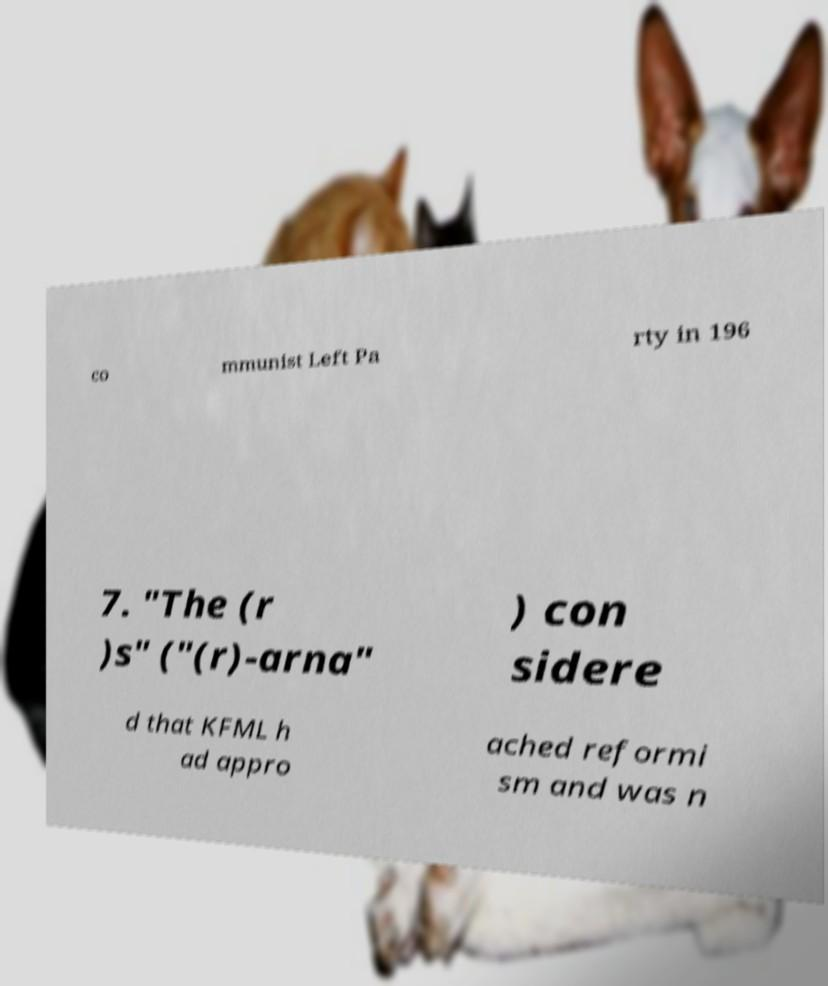Could you extract and type out the text from this image? co mmunist Left Pa rty in 196 7. "The (r )s" ("(r)-arna" ) con sidere d that KFML h ad appro ached reformi sm and was n 